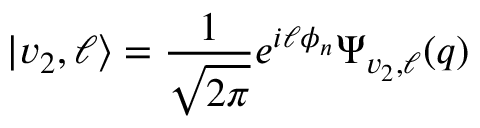Convert formula to latex. <formula><loc_0><loc_0><loc_500><loc_500>| v _ { 2 } , \ell \rangle = \frac { 1 } { \sqrt { 2 \pi } } e ^ { i \ell \phi _ { n } } \Psi _ { v _ { 2 } , \ell } ( q )</formula> 